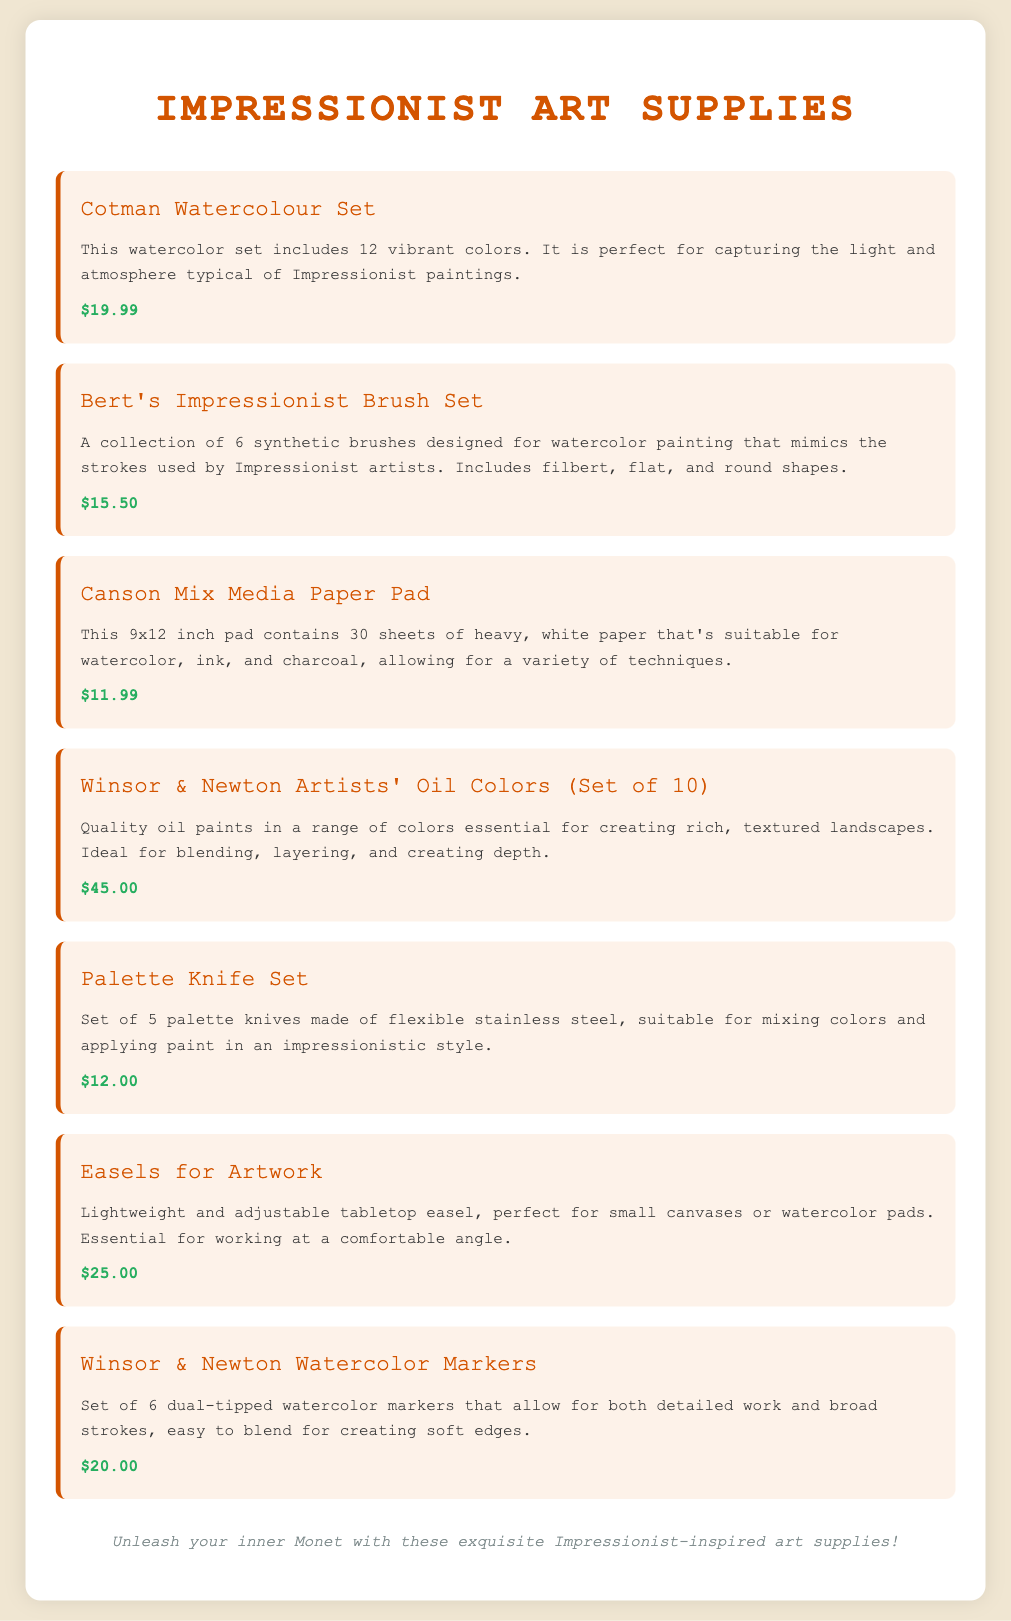What is the price of the Cotman Watercolour Set? The price is listed directly next to the item name in the document.
Answer: $19.99 How many brushes are included in Bert's Impressionist Brush Set? The number of brushes is specified in the description of the item.
Answer: 6 What paper size is the Canson Mix Media Paper Pad? The size of the paper pad is mentioned in the description.
Answer: 9x12 inch Which brand offers the oil colors set? The brand name is noted in the item's title.
Answer: Winsor & Newton What is the total number of sheets in the Canson Mix Media Paper Pad? The total sheets are stated in the item's description.
Answer: 30 sheets What tool is suggested for mixing colors? The suggested tool is indicated in the description of the relevant item.
Answer: Palette Knife Set Which impressionist supply is lightweight and adjustable? The description mentions that it is lightweight and adjustable.
Answer: Easels for Artwork What type of colors does the Winsor & Newton Artists' Oil Colors set include? The document specifies the type of colors in the description.
Answer: Oil paints What is the primary purpose of the Winsor & Newton Watercolor Markers? The item’s description explains their intended use.
Answer: Blending and detailed work 